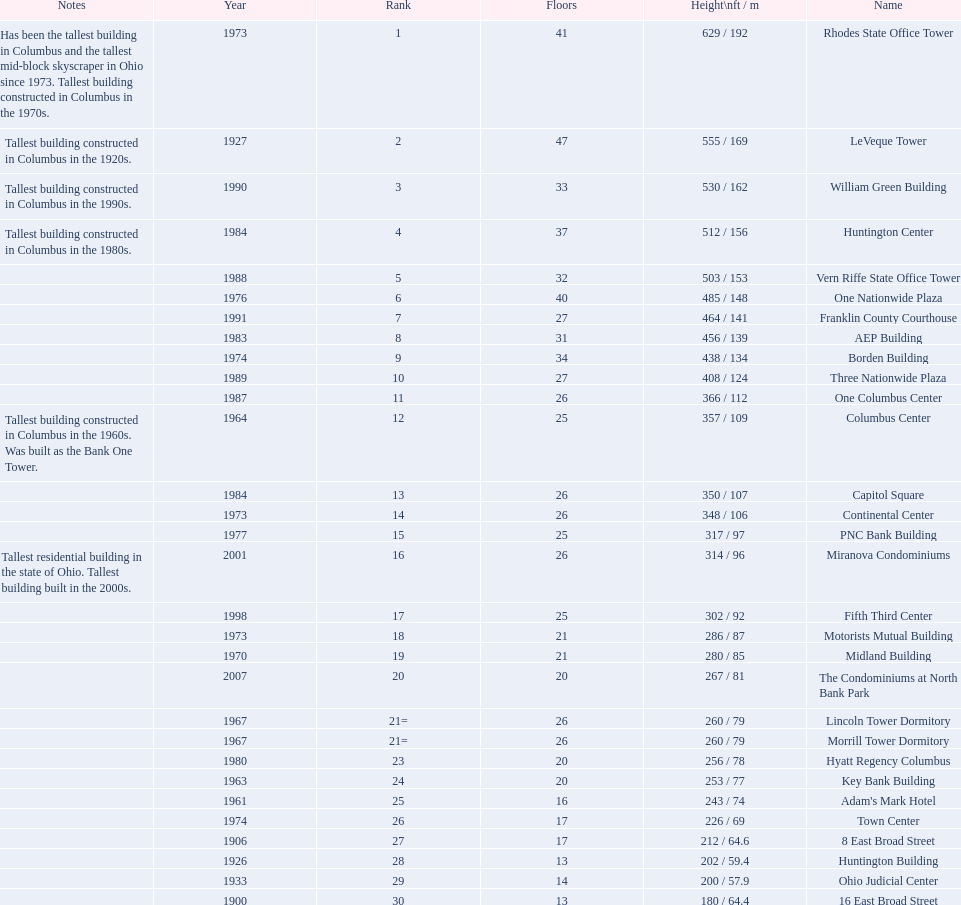How tall is the aep building? 456 / 139. How tall is the one columbus center? 366 / 112. Of these two buildings, which is taller? AEP Building. 